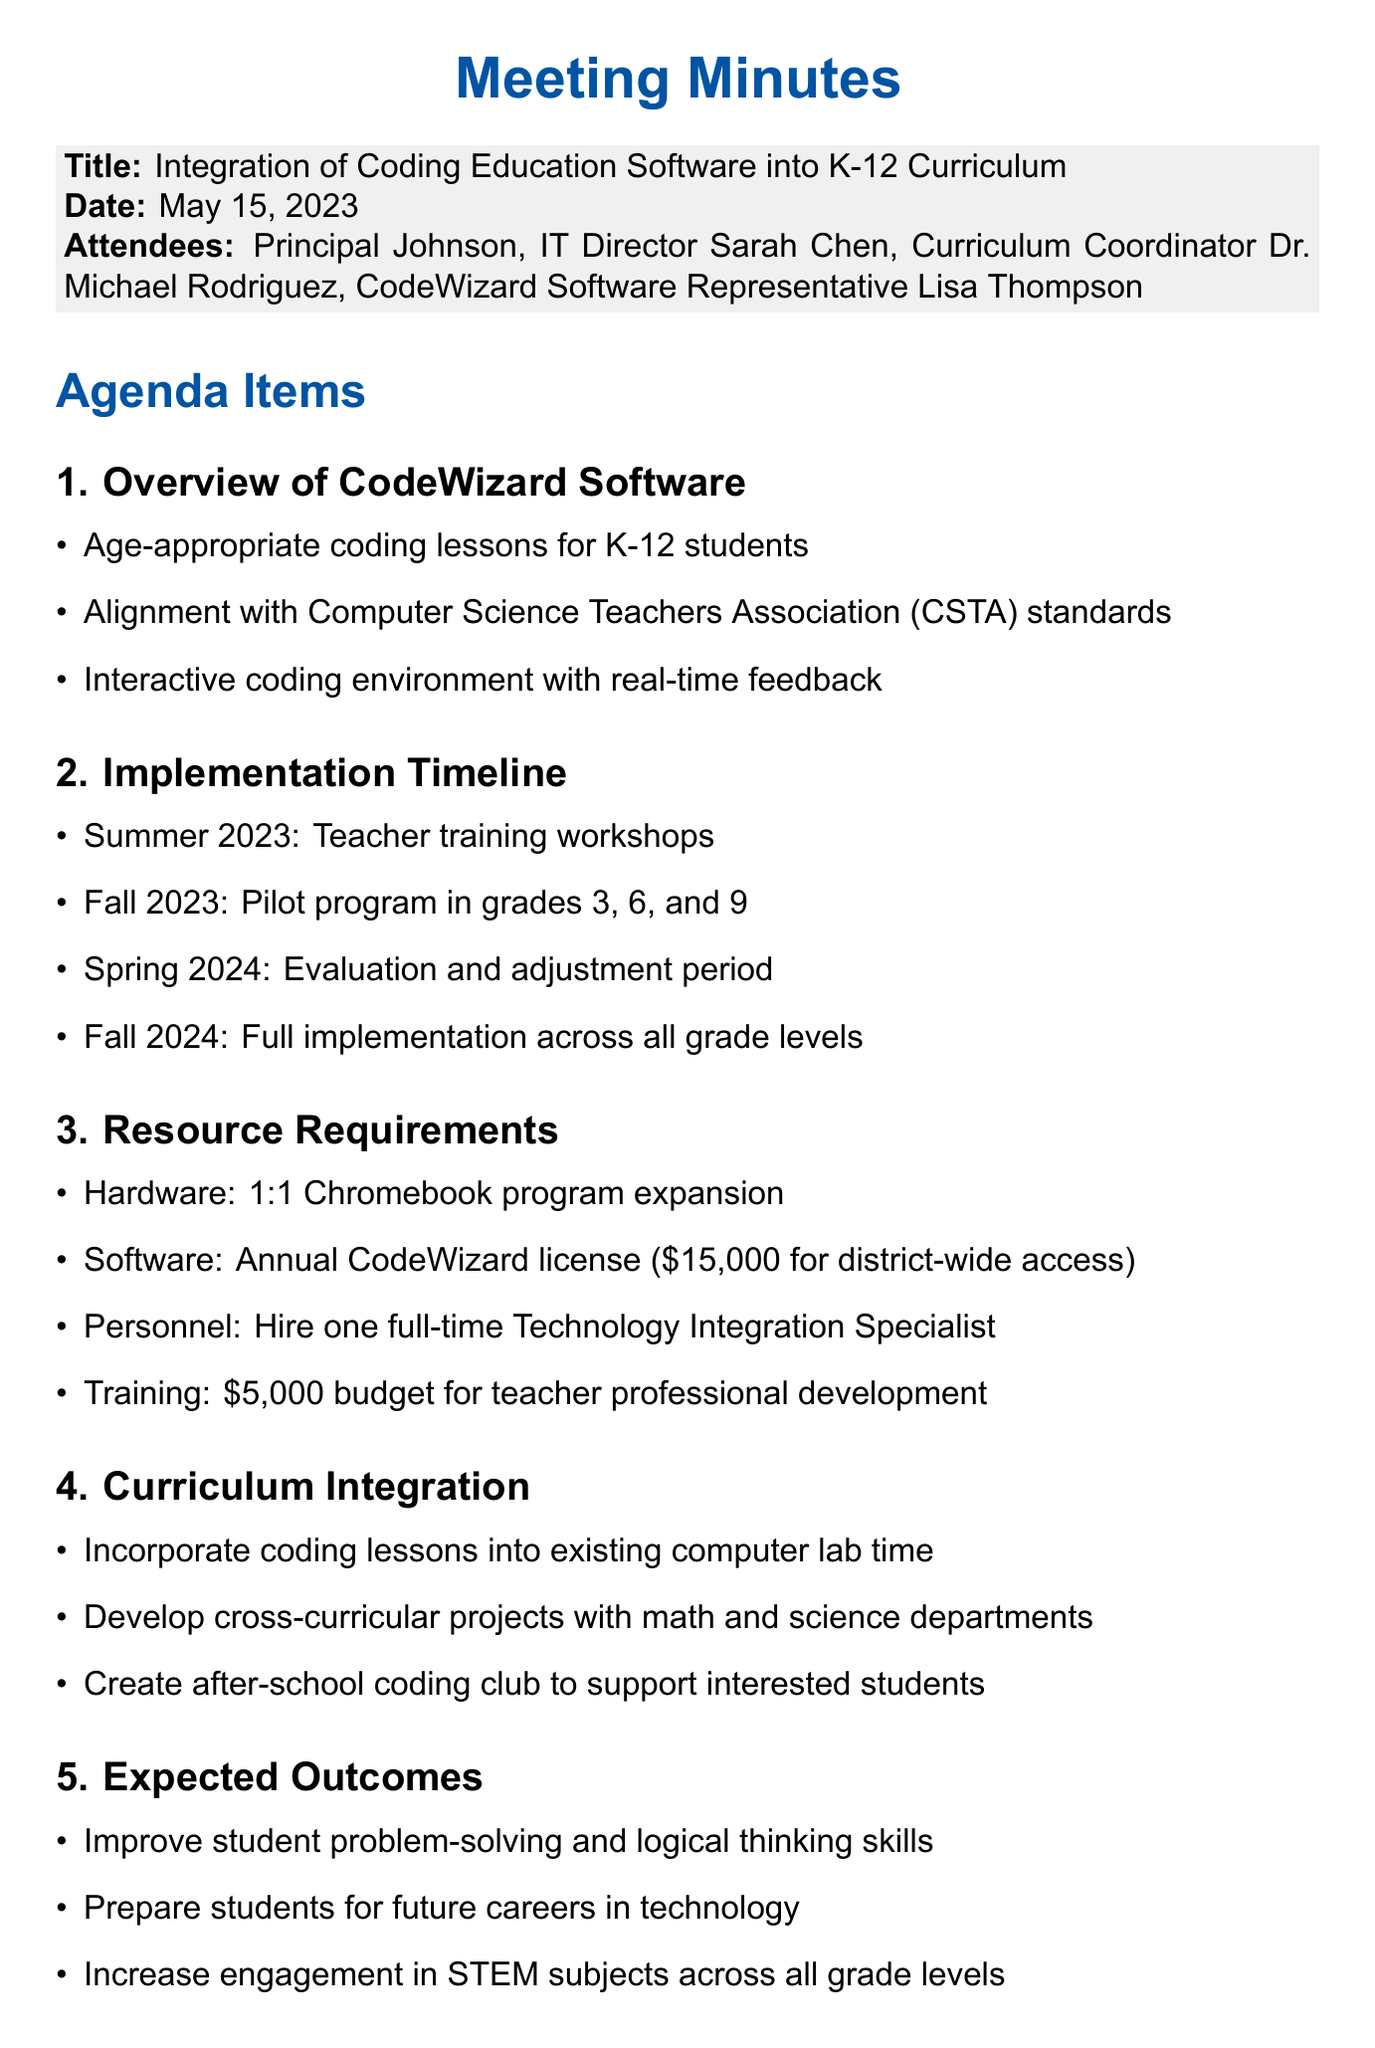What is the date of the meeting? The date of the meeting is stated clearly at the beginning of the document.
Answer: May 15, 2023 Who represented the CodeWizard Software? The attendees list mentions the representative for CodeWizard Software.
Answer: Lisa Thompson What is the budget allocated for teacher training? The resource requirements section details the budget for teacher professional development.
Answer: $5,000 When is the pilot program scheduled to start? The implementation timeline outlines when the pilot program will begin for specific grades.
Answer: Fall 2023 What is a key expected outcome of integrating the software? The expected outcomes section lists several benefits, one being improved skills in a specific area.
Answer: Problem-solving and logical thinking skills What is the total cost for the annual software license? The resource requirements specify the annual cost for district-wide software access.
Answer: $15,000 What position needs to be hired for the implementation? The resource requirements indicate a specific role that needs to be filled for proper integration.
Answer: Technology Integration Specialist How many grades will participate in the pilot program? The implementation timeline specifies which grades are included in the pilot.
Answer: Three grades (3, 6, and 9) What action item involves hardware assessment? The action items section outlines tasks assigned to specific attendees, mentioning hardware.
Answer: IT Director to assess current hardware capabilities and propose upgrades 